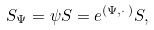<formula> <loc_0><loc_0><loc_500><loc_500>S _ { \Psi } = \psi S = e ^ { ( \Psi , \cdot \, ) } S ,</formula> 